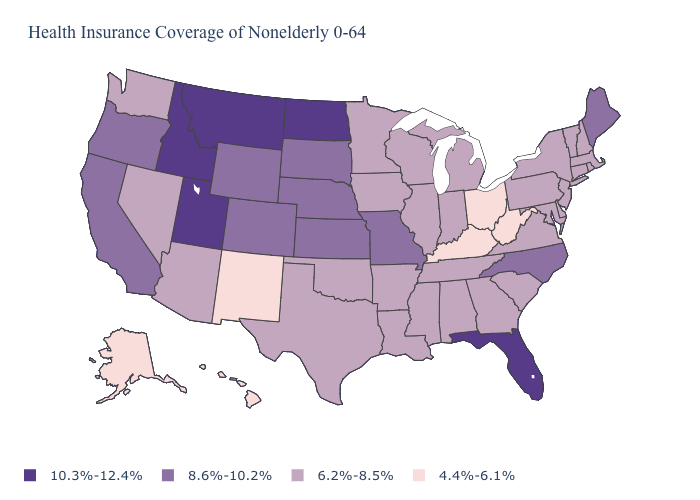Does North Dakota have the highest value in the USA?
Short answer required. Yes. What is the value of Oregon?
Short answer required. 8.6%-10.2%. What is the lowest value in the USA?
Quick response, please. 4.4%-6.1%. Does the map have missing data?
Concise answer only. No. Among the states that border New Jersey , which have the highest value?
Concise answer only. Delaware, New York, Pennsylvania. What is the highest value in the USA?
Short answer required. 10.3%-12.4%. What is the lowest value in the MidWest?
Answer briefly. 4.4%-6.1%. What is the value of Tennessee?
Short answer required. 6.2%-8.5%. Does Massachusetts have the lowest value in the Northeast?
Quick response, please. Yes. Which states have the lowest value in the Northeast?
Answer briefly. Connecticut, Massachusetts, New Hampshire, New Jersey, New York, Pennsylvania, Rhode Island, Vermont. Does Ohio have the highest value in the USA?
Write a very short answer. No. Does Florida have the highest value in the South?
Give a very brief answer. Yes. Which states have the lowest value in the West?
Short answer required. Alaska, Hawaii, New Mexico. 